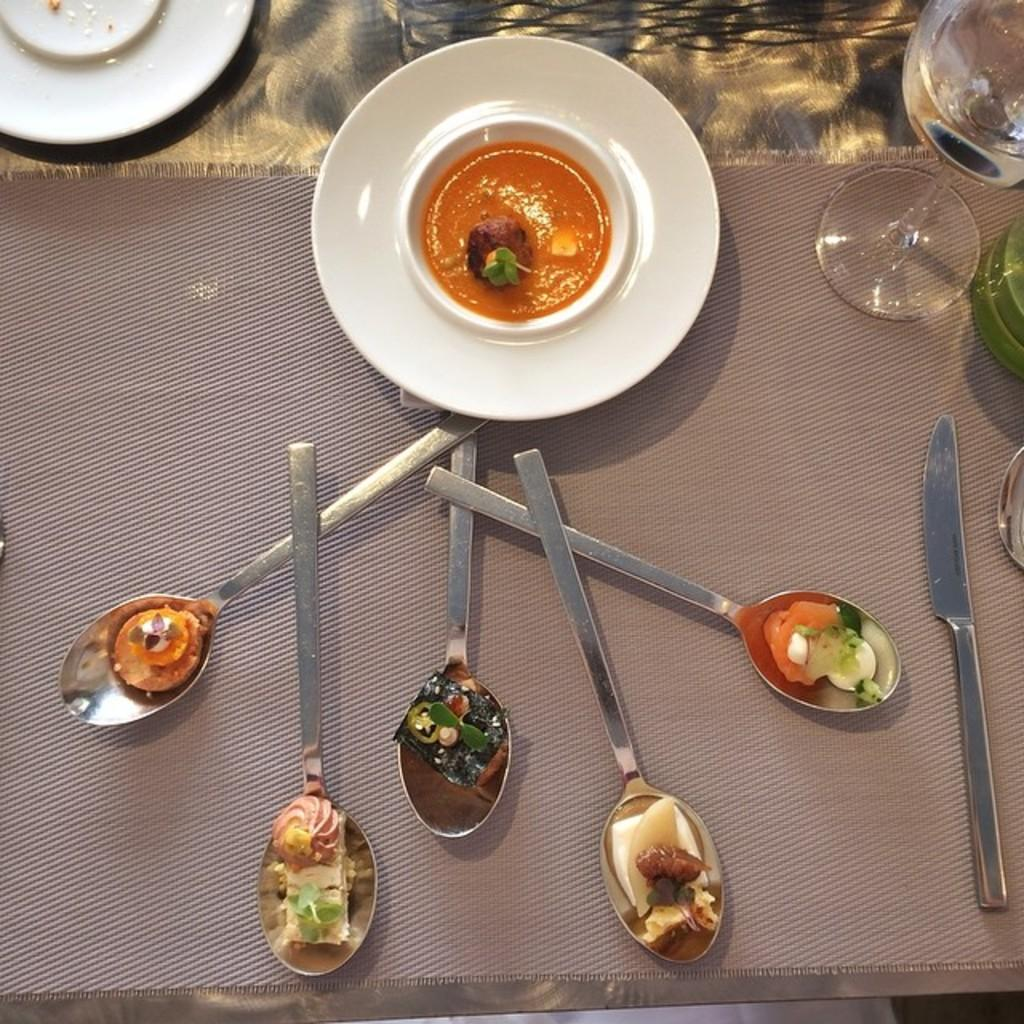What is present on the plate in the image? There is a plate in the image, and on it, there are spoons, a knife, a glass, a cloth, and food items. What type of utensils can be seen on the plate? Spoons and a knife are visible on the plate. What is used for drinking in the image? There is a glass on the plate that can be used for drinking. What is used for cleaning or wiping in the image? A cloth is present on the plate for cleaning or wiping. What can be found on the plate besides utensils and the cloth? There are food items on the plate. Can you see a bee buzzing around the food items on the plate? There is no bee present in the image; it only features a plate with various items on it. 